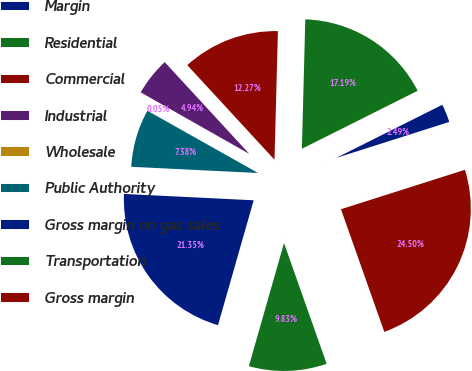Convert chart to OTSL. <chart><loc_0><loc_0><loc_500><loc_500><pie_chart><fcel>Margin<fcel>Residential<fcel>Commercial<fcel>Industrial<fcel>Wholesale<fcel>Public Authority<fcel>Gross margin on gas sales<fcel>Transportation<fcel>Gross margin<nl><fcel>2.49%<fcel>17.19%<fcel>12.27%<fcel>4.94%<fcel>0.05%<fcel>7.38%<fcel>21.35%<fcel>9.83%<fcel>24.5%<nl></chart> 